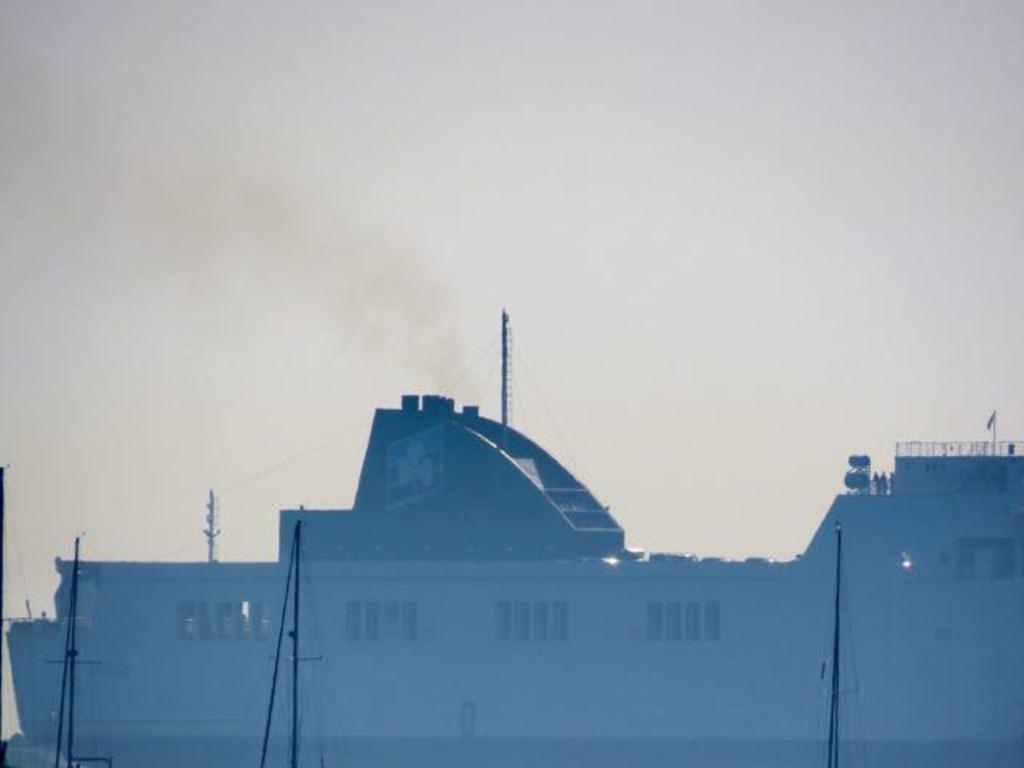How would you summarize this image in a sentence or two? As we can see in the image there is a building, current poles and few people standing on building. On the top there is sky. 